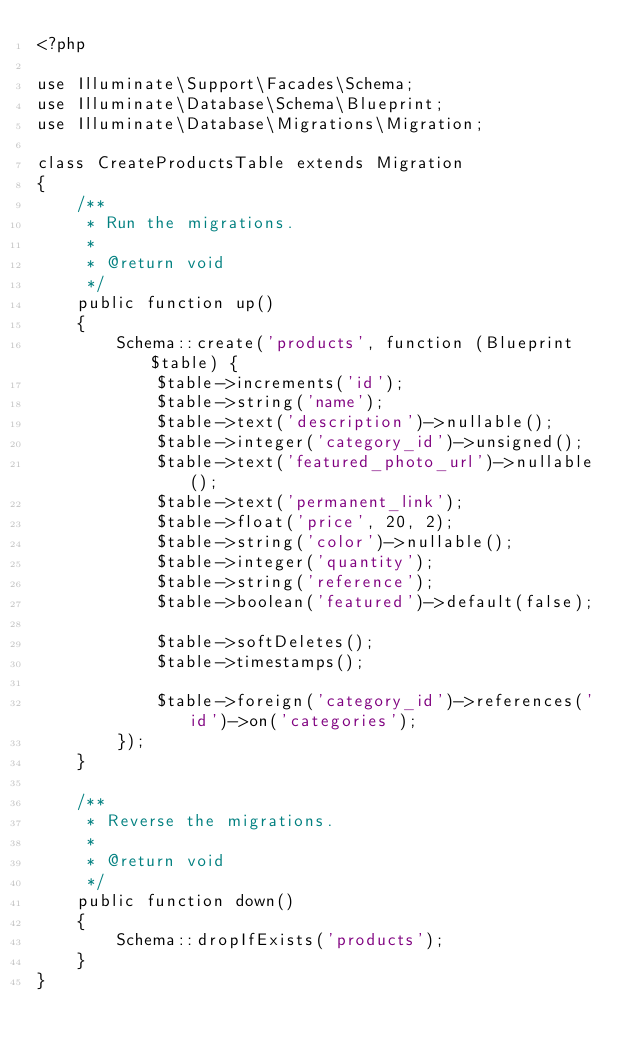Convert code to text. <code><loc_0><loc_0><loc_500><loc_500><_PHP_><?php

use Illuminate\Support\Facades\Schema;
use Illuminate\Database\Schema\Blueprint;
use Illuminate\Database\Migrations\Migration;

class CreateProductsTable extends Migration
{
    /**
     * Run the migrations.
     *
     * @return void
     */
    public function up()
    {
        Schema::create('products', function (Blueprint $table) {
            $table->increments('id');
            $table->string('name');
            $table->text('description')->nullable();
            $table->integer('category_id')->unsigned();
            $table->text('featured_photo_url')->nullable();
            $table->text('permanent_link');
            $table->float('price', 20, 2);
            $table->string('color')->nullable();
            $table->integer('quantity');
            $table->string('reference');
            $table->boolean('featured')->default(false);

            $table->softDeletes();
            $table->timestamps();
            
            $table->foreign('category_id')->references('id')->on('categories');
        });
    }

    /**
     * Reverse the migrations.
     *
     * @return void
     */
    public function down()
    {
        Schema::dropIfExists('products');
    }
}
</code> 